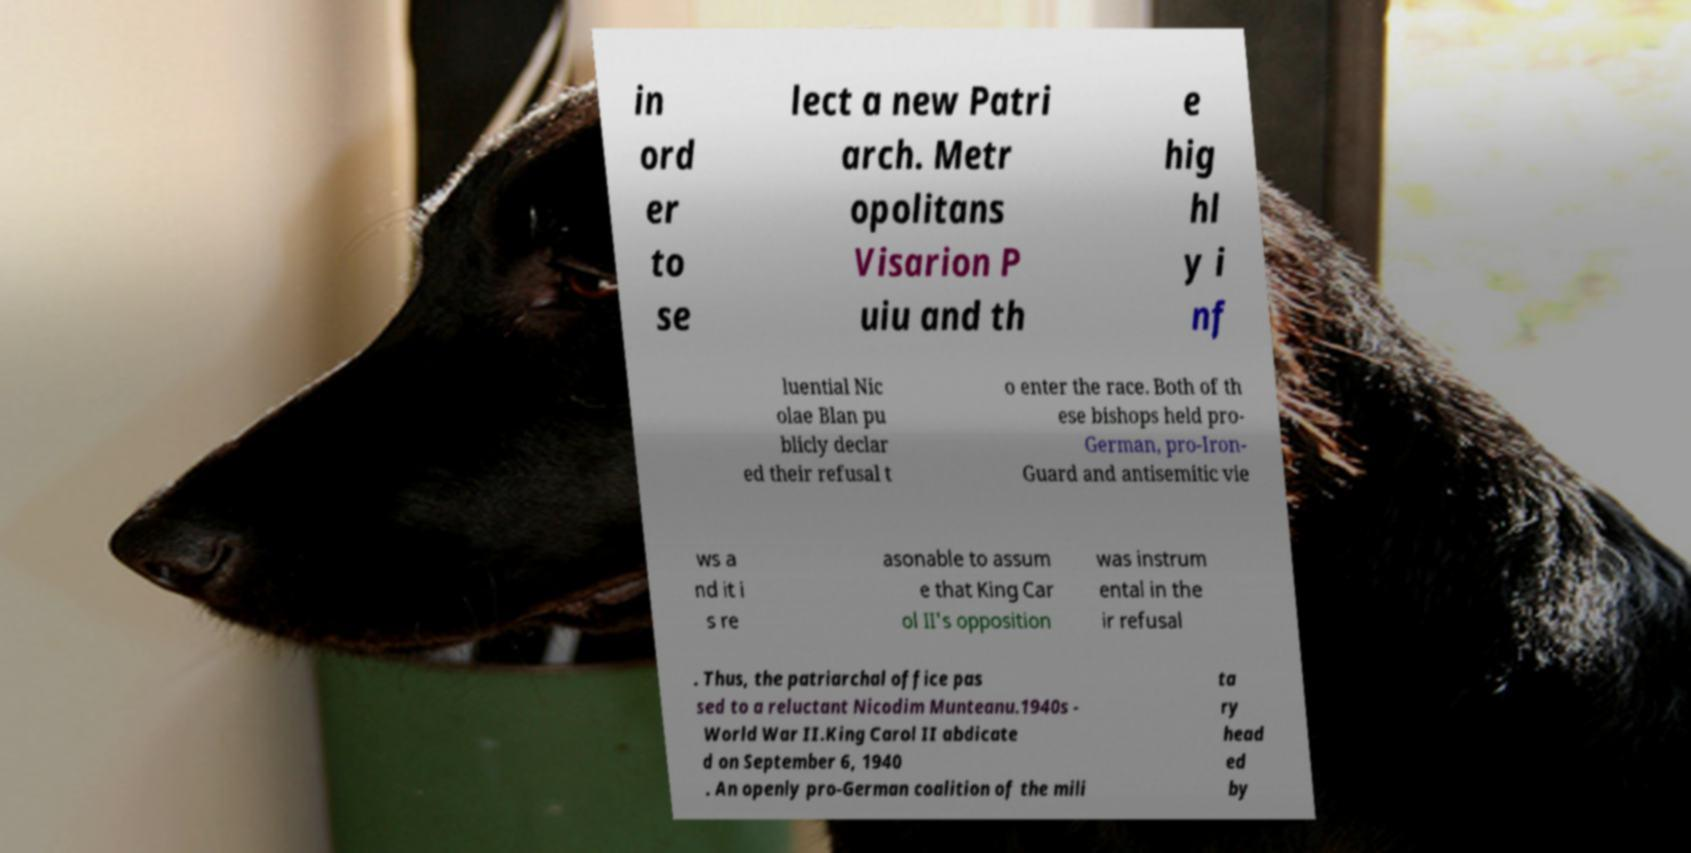Could you extract and type out the text from this image? in ord er to se lect a new Patri arch. Metr opolitans Visarion P uiu and th e hig hl y i nf luential Nic olae Blan pu blicly declar ed their refusal t o enter the race. Both of th ese bishops held pro- German, pro-Iron- Guard and antisemitic vie ws a nd it i s re asonable to assum e that King Car ol II's opposition was instrum ental in the ir refusal . Thus, the patriarchal office pas sed to a reluctant Nicodim Munteanu.1940s - World War II.King Carol II abdicate d on September 6, 1940 . An openly pro-German coalition of the mili ta ry head ed by 